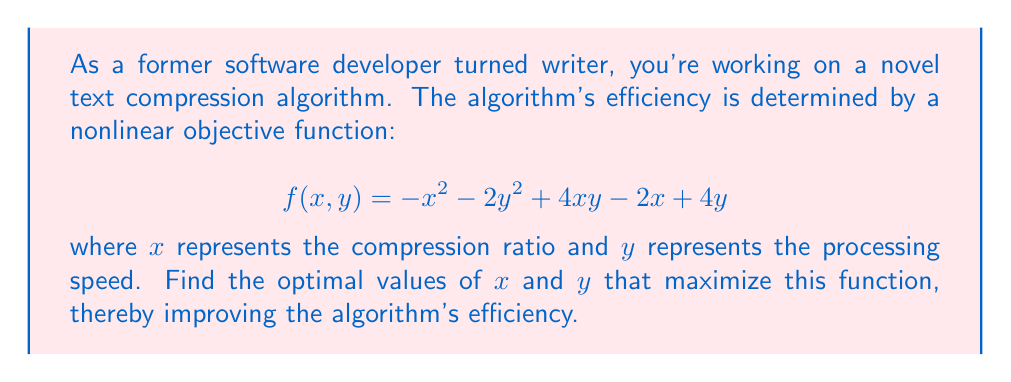Solve this math problem. To find the maximum of this nonlinear function, we need to follow these steps:

1. Calculate the partial derivatives of $f$ with respect to $x$ and $y$:

   $\frac{\partial f}{\partial x} = -2x + 4y - 2$
   $\frac{\partial f}{\partial y} = -4y + 4x + 4$

2. Set both partial derivatives to zero to find the critical points:

   $-2x + 4y - 2 = 0$ ... (1)
   $-4y + 4x + 4 = 0$ ... (2)

3. Solve this system of equations:
   From (2): $y = x + 1$ ... (3)
   
   Substitute (3) into (1):
   $-2x + 4(x + 1) - 2 = 0$
   $-2x + 4x + 4 - 2 = 0$
   $2x + 2 = 0$
   $x = -1$

   Substitute $x = -1$ into (3):
   $y = -1 + 1 = 0$

4. Verify that this critical point $(x, y) = (-1, 0)$ is indeed a maximum:
   Calculate the Hessian matrix:
   
   $H = \begin{bmatrix} 
   \frac{\partial^2 f}{\partial x^2} & \frac{\partial^2 f}{\partial x\partial y} \\
   \frac{\partial^2 f}{\partial y\partial x} & \frac{\partial^2 f}{\partial y^2}
   \end{bmatrix} = \begin{bmatrix}
   -2 & 4 \\
   4 & -4
   \end{bmatrix}$

   The determinant of $H$ is: $(-2)(-4) - (4)(4) = 8 - 16 = -8 < 0$
   
   And $\frac{\partial^2 f}{\partial x^2} = -2 < 0$

   This confirms that $(-1, 0)$ is indeed a local maximum.

5. Therefore, the optimal values are $x = -1$ and $y = 0$.
Answer: $x = -1, y = 0$ 